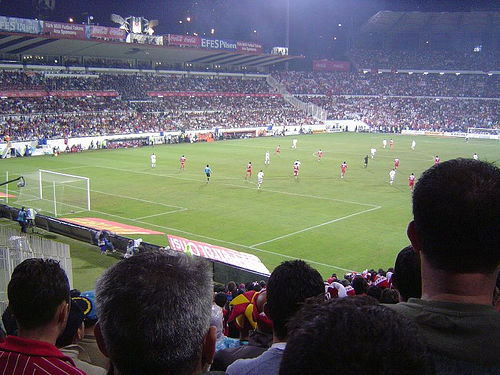<image>
Is the ground under the auditorium? Yes. The ground is positioned underneath the auditorium, with the auditorium above it in the vertical space. Is there a man behind the wall? Yes. From this viewpoint, the man is positioned behind the wall, with the wall partially or fully occluding the man. Is the playground behind the man? No. The playground is not behind the man. From this viewpoint, the playground appears to be positioned elsewhere in the scene. Is the player above the field? No. The player is not positioned above the field. The vertical arrangement shows a different relationship. 